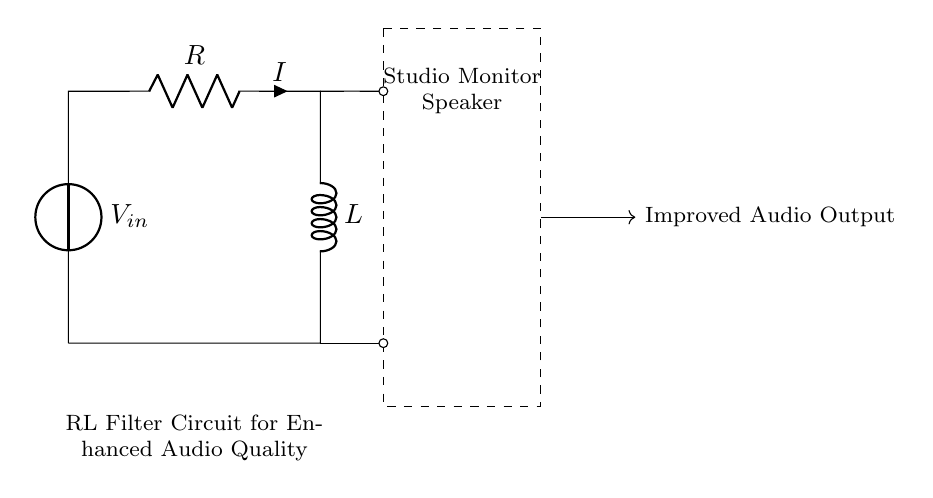What is the input voltage in this circuit? The input voltage is indicated by the voltage source symbol labeled V_in. There is no specific value given in the circuit diagram, so we identify it simply as V_in.
Answer: V_in What is the resistance value in this circuit? The resistance is labeled as R in the circuit diagram. No numerical value is provided, but it is designated simply as R.
Answer: R What is the inductance in this circuit? The inductance is labeled as L in the circuit diagram. Like the resistance, there is no specific value, so it is identified as L.
Answer: L What component is connected to the input voltage? The component directly connected to the input voltage source is the resistor, as it is the first element in the circuit following V_in.
Answer: Resistor Explain how the current flows in this RL circuit. Current flows from the voltage source, through the resistor R, and into the inductor L. After passing through both components, the current completes the circuit by returning to the ground, forming a closed loop. This means that the current flows in the order: V_in → R → L → ground.
Answer: From V_in through R to L and back to ground What is the purpose of the RL filter in studio monitor speakers? The RL filter works by allowing certain frequency signals to pass while attenuating others. Specifically, it smooths out high-frequency noise and improves overall audio quality, making it beneficial for audio production and editing.
Answer: Improved audio quality What happens to high-frequency signals in this RL circuit? High-frequency signals are attenuated by the inductor L, which opposes changes in current flow, thereby filtering out unwanted high frequencies and only allowing lower frequencies to pass through to the speaker.
Answer: Attenuated 